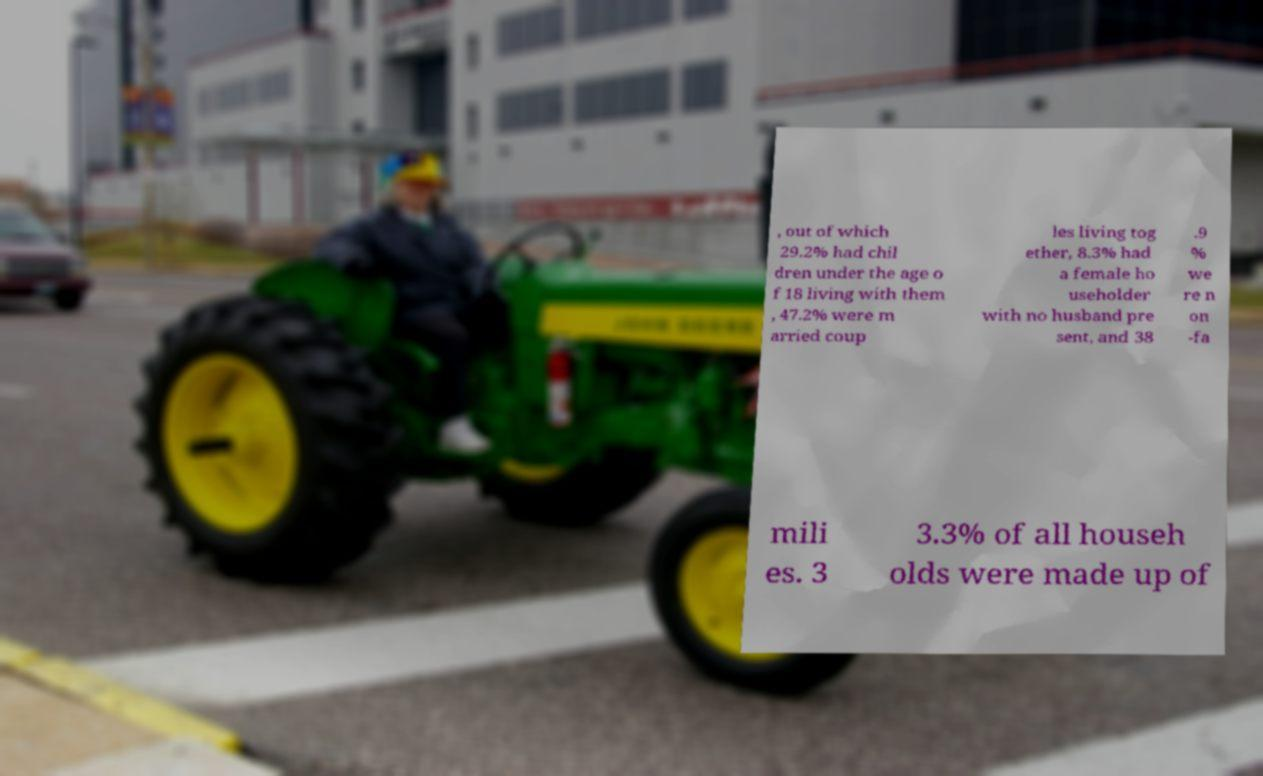There's text embedded in this image that I need extracted. Can you transcribe it verbatim? , out of which 29.2% had chil dren under the age o f 18 living with them , 47.2% were m arried coup les living tog ether, 8.3% had a female ho useholder with no husband pre sent, and 38 .9 % we re n on -fa mili es. 3 3.3% of all househ olds were made up of 